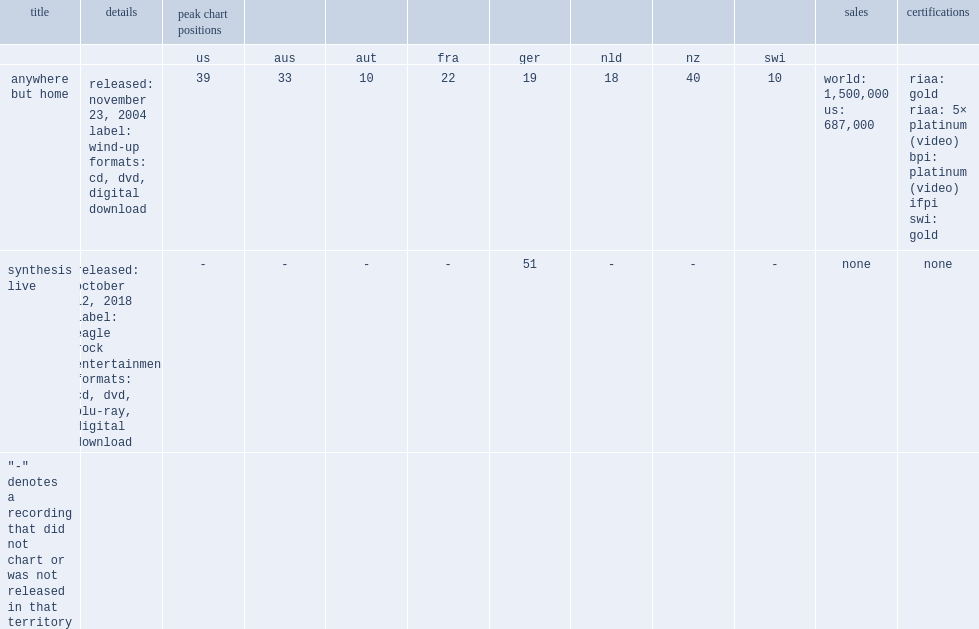How many units did evanescence s anywhere but home sell in the united states? World: 1,500,000 us: 687,000. Would you be able to parse every entry in this table? {'header': ['title', 'details', 'peak chart positions', '', '', '', '', '', '', '', 'sales', 'certifications'], 'rows': [['', '', 'us', 'aus', 'aut', 'fra', 'ger', 'nld', 'nz', 'swi', '', ''], ['anywhere but home', 'released: november 23, 2004 label: wind-up formats: cd, dvd, digital download', '39', '33', '10', '22', '19', '18', '40', '10', 'world: 1,500,000 us: 687,000', 'riaa: gold riaa: 5× platinum (video) bpi: platinum (video) ifpi swi: gold'], ['synthesis live', 'released: october 12, 2018 label: eagle rock entertainment formats: cd, dvd, blu-ray, digital download', '-', '-', '-', '-', '51', '-', '-', '-', 'none', 'none'], ['"-" denotes a recording that did not chart or was not released in that territory', '', '', '', '', '', '', '', '', '', '', '']]} 